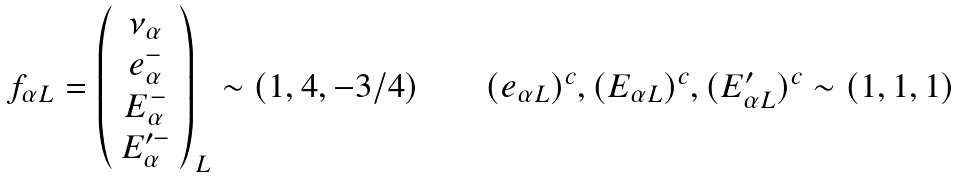Convert formula to latex. <formula><loc_0><loc_0><loc_500><loc_500>\begin{array} { c c c c c } f _ { \alpha L } = \left ( \begin{array} { c } \nu _ { \alpha } \\ e _ { \alpha } ^ { - } \\ E _ { \alpha } ^ { - } \\ E _ { \alpha } ^ { \prime - } \end{array} \right ) _ { L } \sim ( 1 , 4 , - 3 / 4 ) & & & & ( e _ { \alpha L } ) ^ { c } , ( E _ { \alpha L } ) ^ { c } , ( E _ { \alpha L } ^ { \prime } ) ^ { c } \sim ( 1 , 1 , 1 ) \end{array}</formula> 